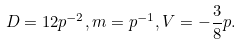<formula> <loc_0><loc_0><loc_500><loc_500>D = 1 2 p ^ { - 2 } , m = p ^ { - 1 } , V = - \frac { 3 } { 8 } p .</formula> 